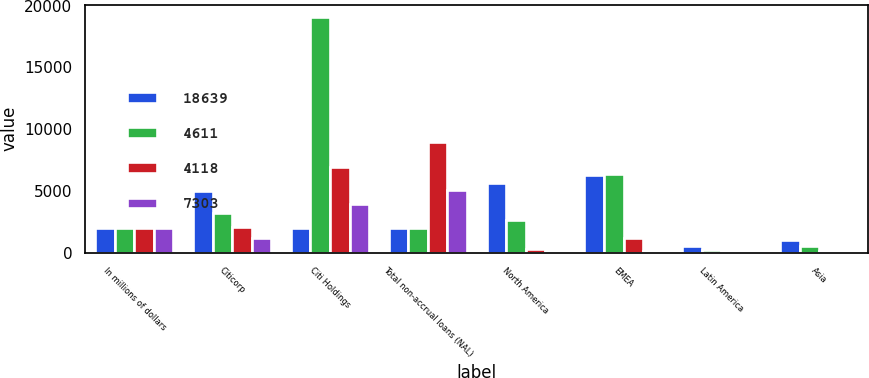Convert chart. <chart><loc_0><loc_0><loc_500><loc_500><stacked_bar_chart><ecel><fcel>In millions of dollars<fcel>Citicorp<fcel>Citi Holdings<fcel>Total non-accrual loans (NAL)<fcel>North America<fcel>EMEA<fcel>Latin America<fcel>Asia<nl><fcel>18639<fcel>2009<fcel>4968<fcel>2007<fcel>2007<fcel>5621<fcel>6308<fcel>569<fcel>1047<nl><fcel>4611<fcel>2008<fcel>3193<fcel>19104<fcel>2007<fcel>2660<fcel>6330<fcel>229<fcel>513<nl><fcel>4118<fcel>2007<fcel>2027<fcel>6941<fcel>8968<fcel>291<fcel>1152<fcel>119<fcel>103<nl><fcel>7303<fcel>2006<fcel>1141<fcel>3906<fcel>5047<fcel>68<fcel>128<fcel>152<fcel>88<nl></chart> 